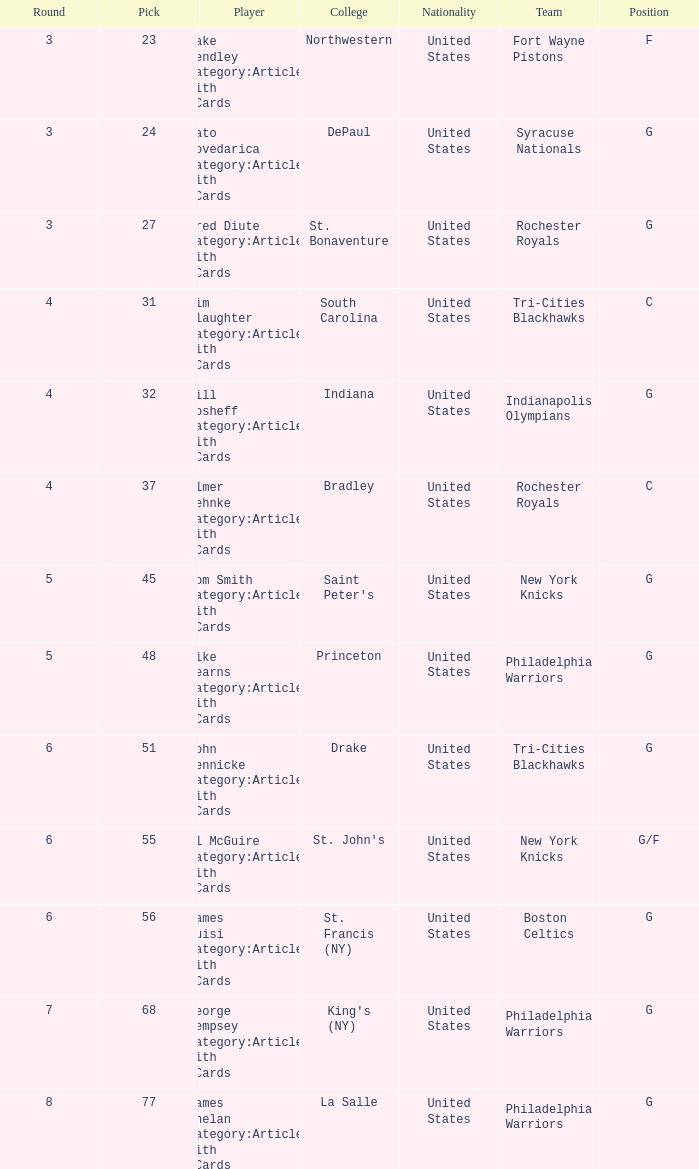What is the lowest pick number for players from king's (ny)? 68.0. 